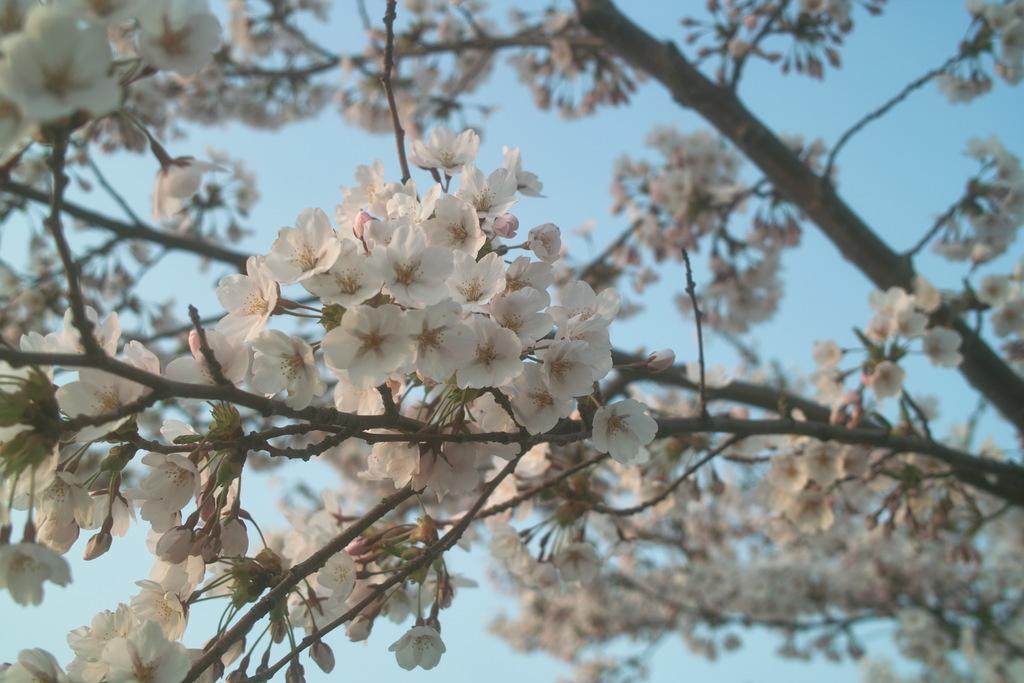Can you describe this image briefly? In this picture we can observe white color flowers to the tree. In the background we can observe a sky. 